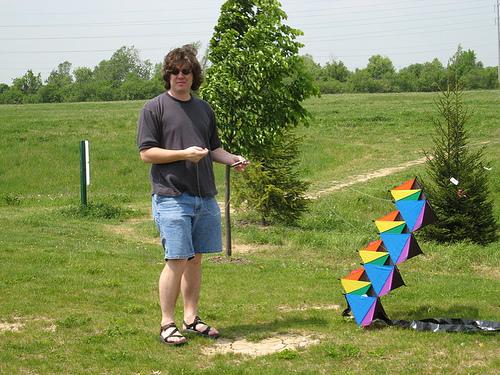Is it daytime?
Answer briefly. Yes. What does the man have in his hand?
Write a very short answer. Kite string. How can you tell the wind is coming from the left?
Keep it brief. Hair. 